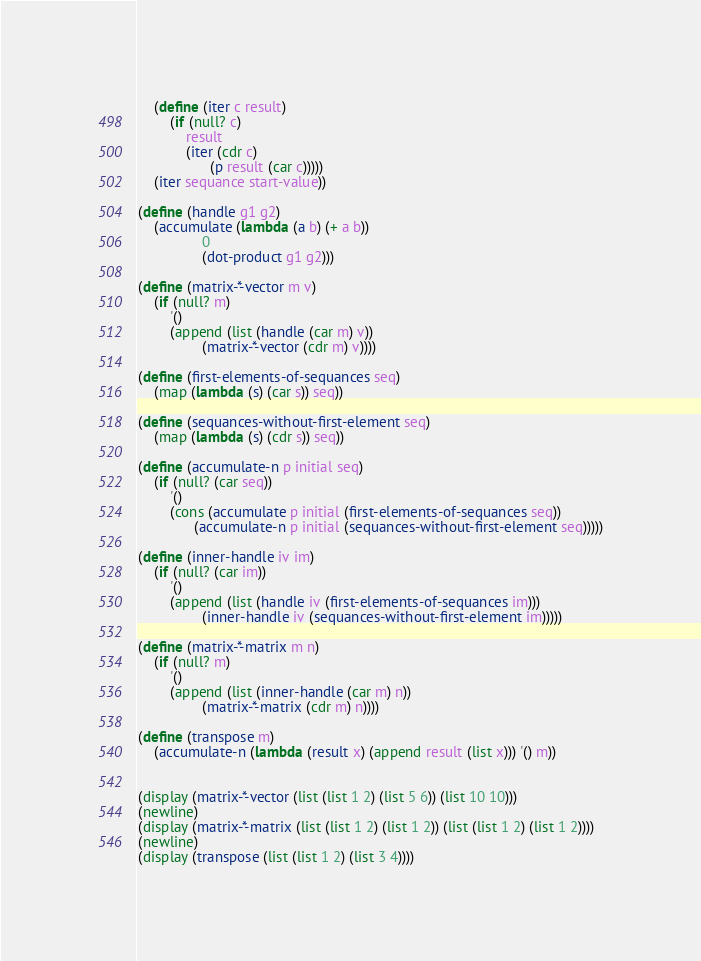<code> <loc_0><loc_0><loc_500><loc_500><_Scheme_>    (define (iter c result)
        (if (null? c)
            result
            (iter (cdr c)
                  (p result (car c)))))
    (iter sequance start-value))

(define (handle g1 g2)
    (accumulate (lambda (a b) (+ a b))
                0
                (dot-product g1 g2)))

(define (matrix-*-vector m v)
    (if (null? m)
        '()
        (append (list (handle (car m) v))
                (matrix-*-vector (cdr m) v))))

(define (first-elements-of-sequances seq)
    (map (lambda (s) (car s)) seq))

(define (sequances-without-first-element seq)
    (map (lambda (s) (cdr s)) seq))

(define (accumulate-n p initial seq)
    (if (null? (car seq))
        '()
        (cons (accumulate p initial (first-elements-of-sequances seq))
              (accumulate-n p initial (sequances-without-first-element seq)))))

(define (inner-handle iv im)
    (if (null? (car im))
        '()
        (append (list (handle iv (first-elements-of-sequances im)))
                (inner-handle iv (sequances-without-first-element im)))))

(define (matrix-*-matrix m n)
    (if (null? m)
        '()
        (append (list (inner-handle (car m) n))
                (matrix-*-matrix (cdr m) n))))

(define (transpose m)
    (accumulate-n (lambda (result x) (append result (list x))) '() m))


(display (matrix-*-vector (list (list 1 2) (list 5 6)) (list 10 10)))
(newline)
(display (matrix-*-matrix (list (list 1 2) (list 1 2)) (list (list 1 2) (list 1 2))))
(newline)
(display (transpose (list (list 1 2) (list 3 4))))
</code> 